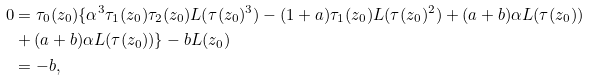<formula> <loc_0><loc_0><loc_500><loc_500>0 & = \tau _ { 0 } ( z _ { 0 } ) \{ \alpha ^ { 3 } \tau _ { 1 } ( z _ { 0 } ) \tau _ { 2 } ( z _ { 0 } ) L ( \tau ( z _ { 0 } ) ^ { 3 } ) - ( 1 + a ) \tau _ { 1 } ( z _ { 0 } ) L ( \tau ( z _ { 0 } ) ^ { 2 } ) + ( a + b ) \alpha L ( \tau ( z _ { 0 } ) ) \\ & + ( a + b ) \alpha L ( \tau ( z _ { 0 } ) ) \} - b L ( z _ { 0 } ) \\ & = - b ,</formula> 